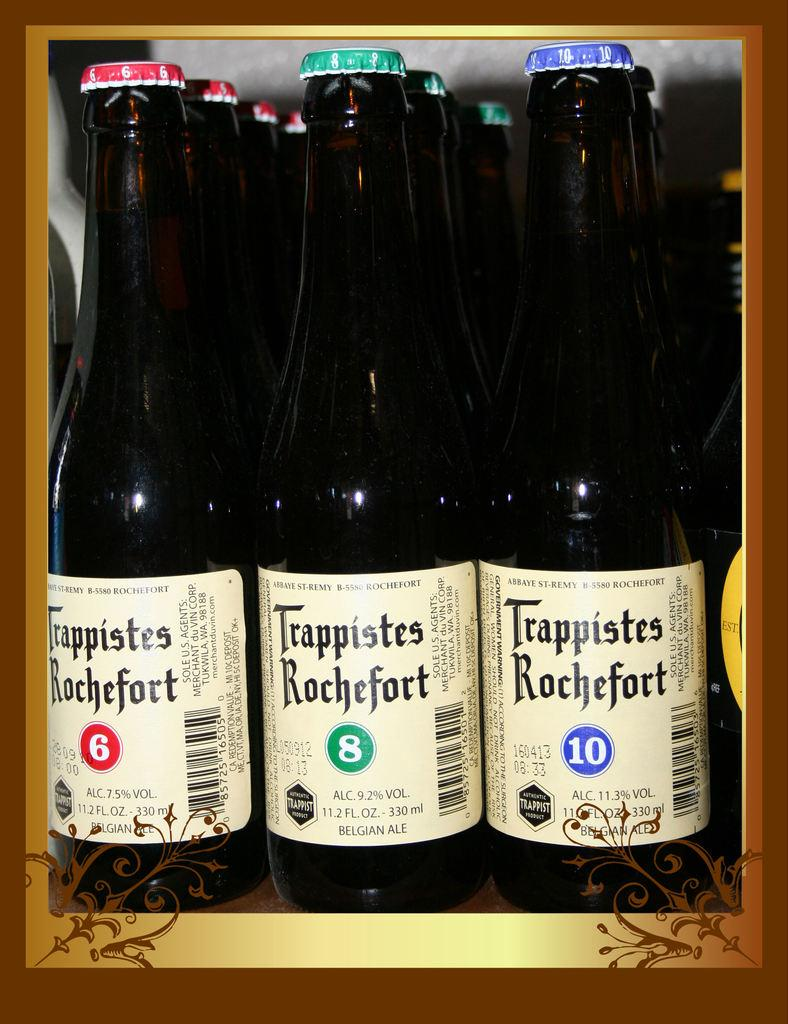<image>
Summarize the visual content of the image. Three different types of Trappistes Rochefort are lined up next to each other. 